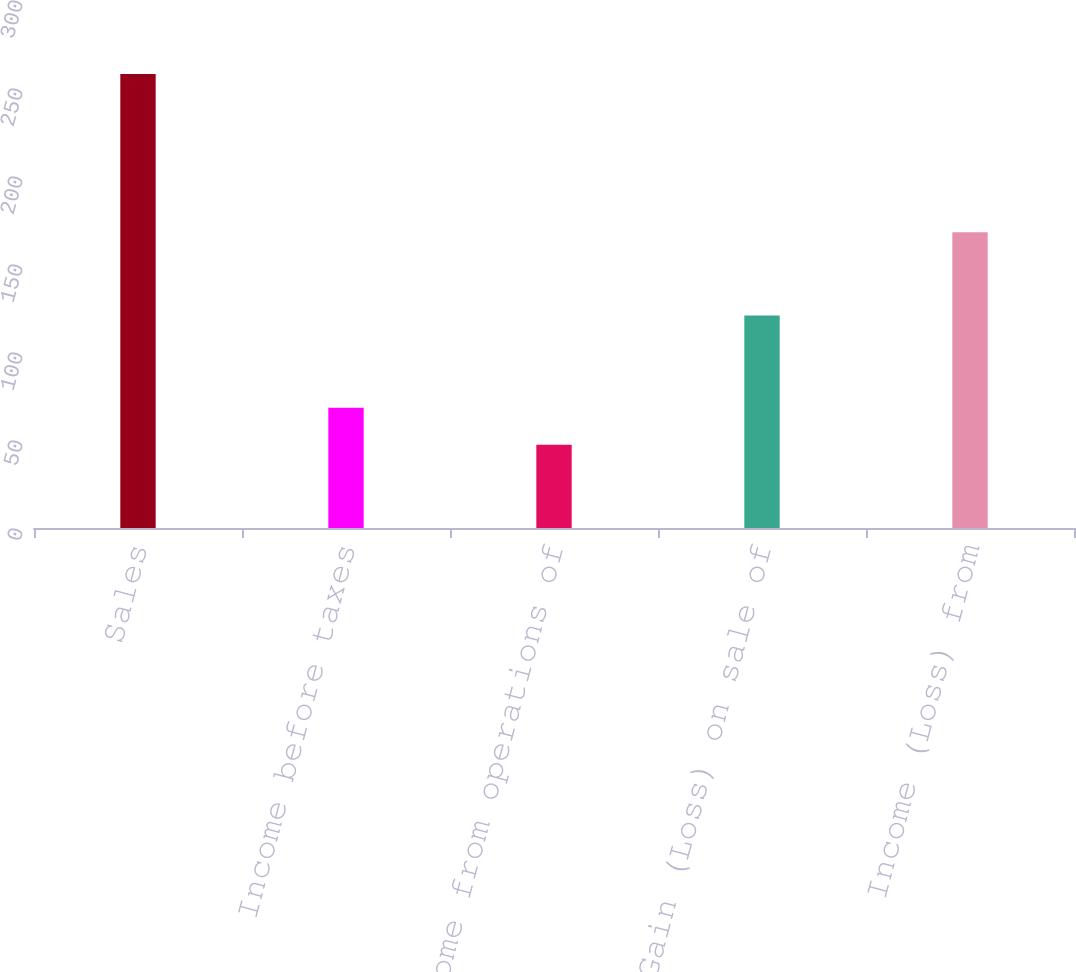Convert chart to OTSL. <chart><loc_0><loc_0><loc_500><loc_500><bar_chart><fcel>Sales<fcel>Income before taxes<fcel>Income from operations of<fcel>Gain (Loss) on sale of<fcel>Income (Loss) from<nl><fcel>258<fcel>68.37<fcel>47.3<fcel>120.8<fcel>168.1<nl></chart> 